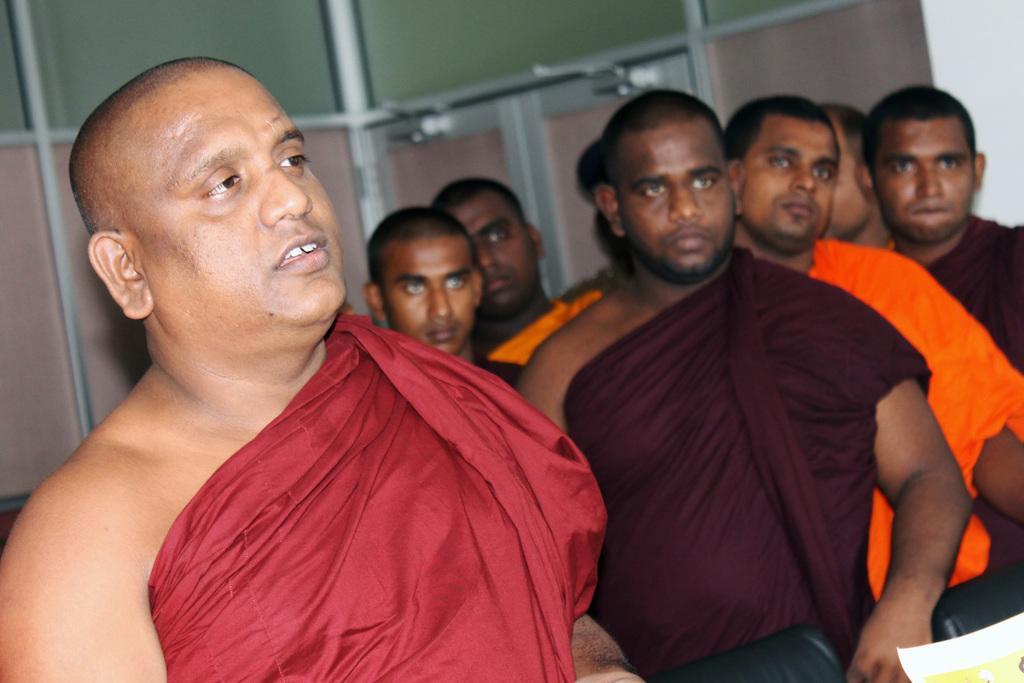In one or two sentences, can you explain what this image depicts? In the picture I can see a man on the left side wearing a red colored cloth and looks like he is speaking. I can see a few men on the right side. There is a paper on the bottom right side of the picture. In the background, I can see the glass windows. 